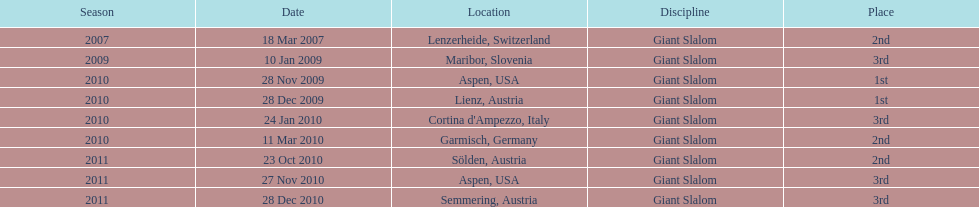How many racing events took place in 2010? 5. 